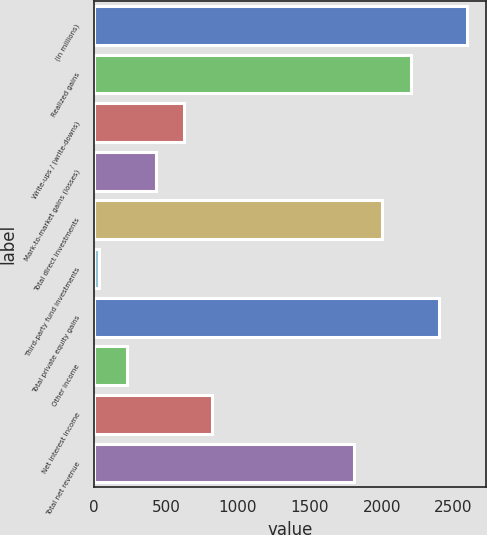<chart> <loc_0><loc_0><loc_500><loc_500><bar_chart><fcel>(in millions)<fcel>Realized gains<fcel>Write-ups / (write-downs)<fcel>Mark-to-market gains (losses)<fcel>Total direct investments<fcel>Third-party fund investments<fcel>Total private equity gains<fcel>Other income<fcel>Net interest income<fcel>Total net revenue<nl><fcel>2595<fcel>2201<fcel>625<fcel>428<fcel>2004<fcel>34<fcel>2398<fcel>231<fcel>822<fcel>1807<nl></chart> 